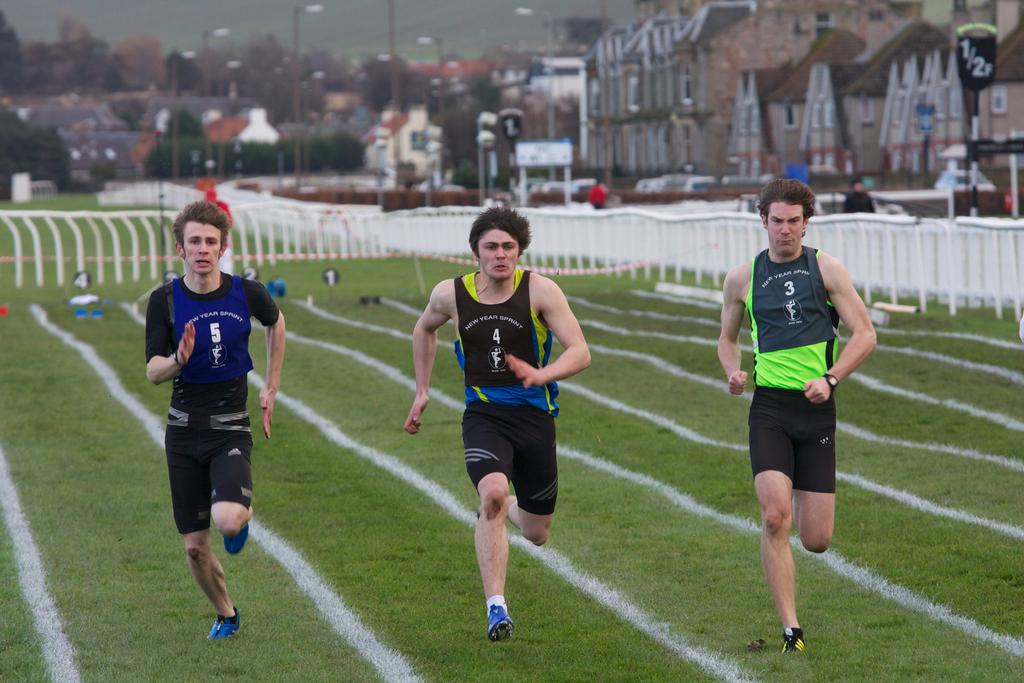What is the number of the player in blue?
Ensure brevity in your answer.  5. What is the number of the player in green?
Provide a short and direct response. 3. 